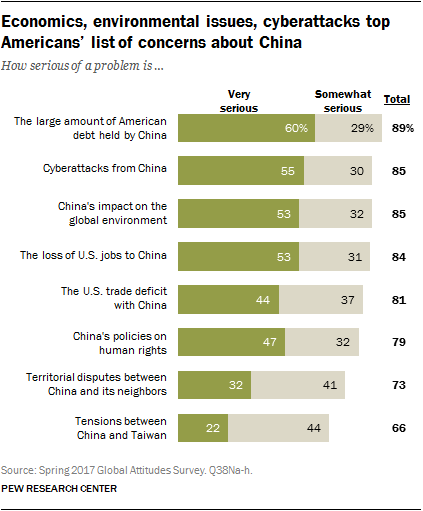Specify some key components in this picture. The data indicates that a significant majority of American debt, approximately 89%, is held by China, with the majority of this debt falling into the category of "very serious" and "somewhat serious." This highlights the potential vulnerability of the United States to economic pressure from China due to its significant debt obligations. Two options are presented in response to the question: 'What are the two options given to the question? [Very serious, Somewhat serious]...' 